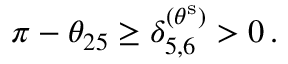<formula> <loc_0><loc_0><loc_500><loc_500>\pi - \theta _ { 2 5 } \geq \delta _ { 5 , 6 } ^ { ( \theta ^ { s } ) } > 0 \, .</formula> 